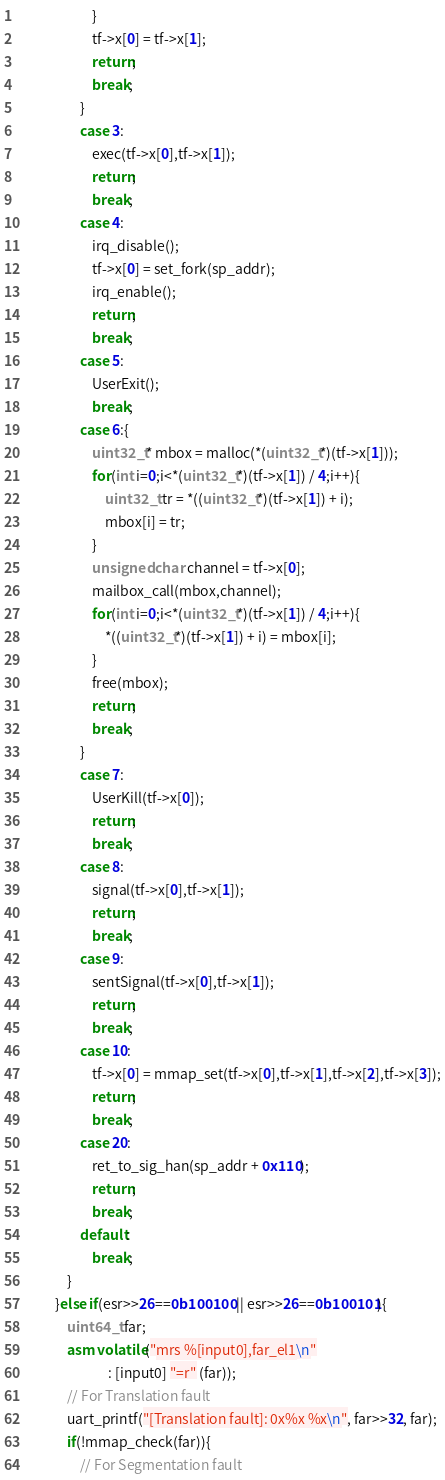Convert code to text. <code><loc_0><loc_0><loc_500><loc_500><_C_>                        }
                        tf->x[0] = tf->x[1];
                        return;
                        break;
                    }
                    case 3:
                        exec(tf->x[0],tf->x[1]);
                        return;
                        break;
                    case 4:
                        irq_disable();
                        tf->x[0] = set_fork(sp_addr);
                        irq_enable();
                        return;
                        break;
                    case 5:
                        UserExit();
                        break;
                    case 6:{
                        uint32_t* mbox = malloc(*(uint32_t*)(tf->x[1]));
                        for(int i=0;i<*(uint32_t*)(tf->x[1]) / 4;i++){
                            uint32_t tr = *((uint32_t*)(tf->x[1]) + i);
                            mbox[i] = tr;
                        }
                        unsigned char channel = tf->x[0];
                        mailbox_call(mbox,channel);
                        for(int i=0;i<*(uint32_t*)(tf->x[1]) / 4;i++){
                            *((uint32_t*)(tf->x[1]) + i) = mbox[i];
                        }
                        free(mbox);
                        return;
                        break;
                    }
                    case 7:
                        UserKill(tf->x[0]);
                        return;
                        break;
                    case 8:
                        signal(tf->x[0],tf->x[1]);
                        return;
                        break;
                    case 9:
                        sentSignal(tf->x[0],tf->x[1]);
                        return;
                        break;
                    case 10:
                        tf->x[0] = mmap_set(tf->x[0],tf->x[1],tf->x[2],tf->x[3]);
                        return;
                        break;
                    case 20:
                        ret_to_sig_han(sp_addr + 0x110);
                        return;
                        break;
                    default:
                        break;
                }
            }else if(esr>>26==0b100100 || esr>>26==0b100101){
                uint64_t far;
                asm volatile("mrs %[input0],far_el1\n"
                             : [input0] "=r" (far));
                // For Translation fault
                uart_printf("[Translation fault]: 0x%x %x\n", far>>32, far);
                if(!mmap_check(far)){
                    // For Segmentation fault</code> 